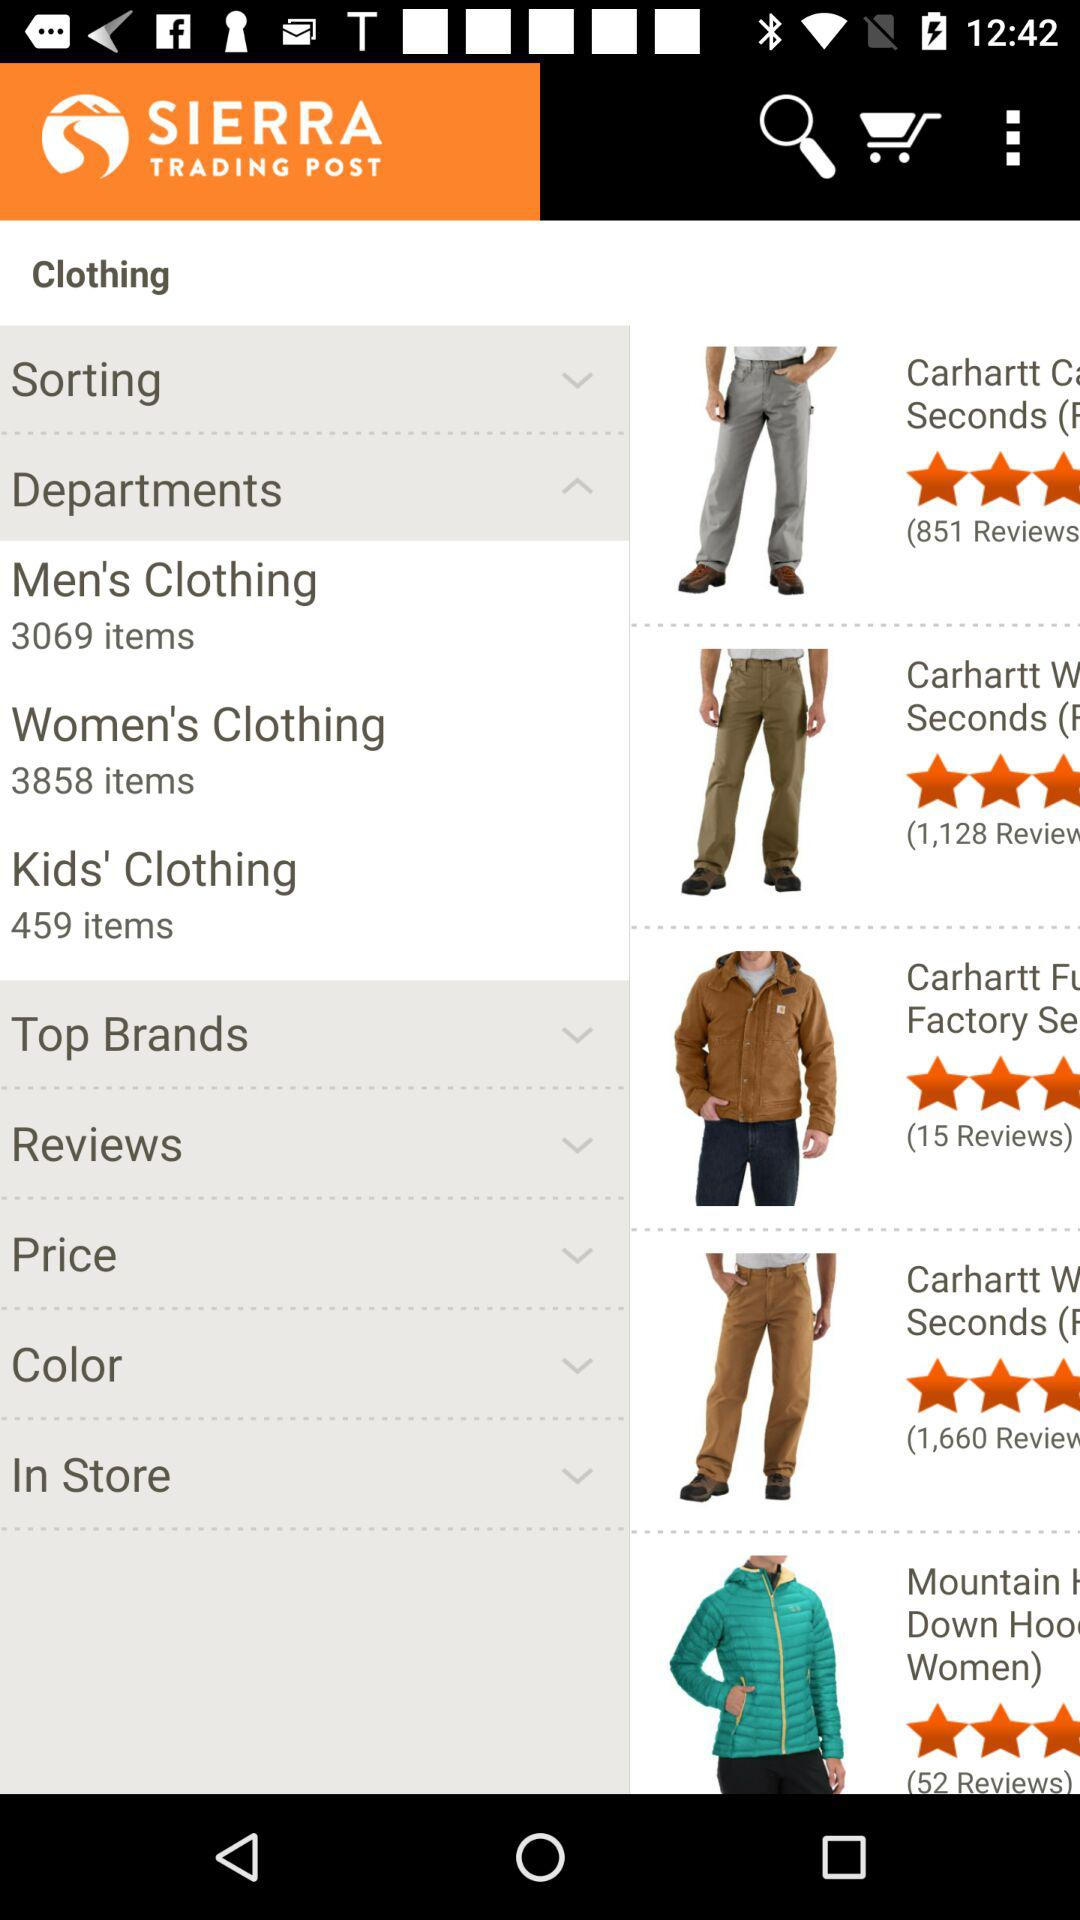How many items are in kids' clothing? In kids' clothing, there are 459 items. 